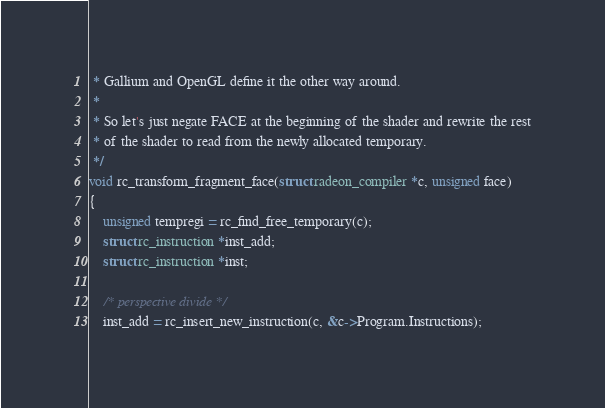Convert code to text. <code><loc_0><loc_0><loc_500><loc_500><_C_> * Gallium and OpenGL define it the other way around.
 *
 * So let's just negate FACE at the beginning of the shader and rewrite the rest
 * of the shader to read from the newly allocated temporary.
 */
void rc_transform_fragment_face(struct radeon_compiler *c, unsigned face)
{
	unsigned tempregi = rc_find_free_temporary(c);
	struct rc_instruction *inst_add;
	struct rc_instruction *inst;

	/* perspective divide */
	inst_add = rc_insert_new_instruction(c, &c->Program.Instructions);</code> 